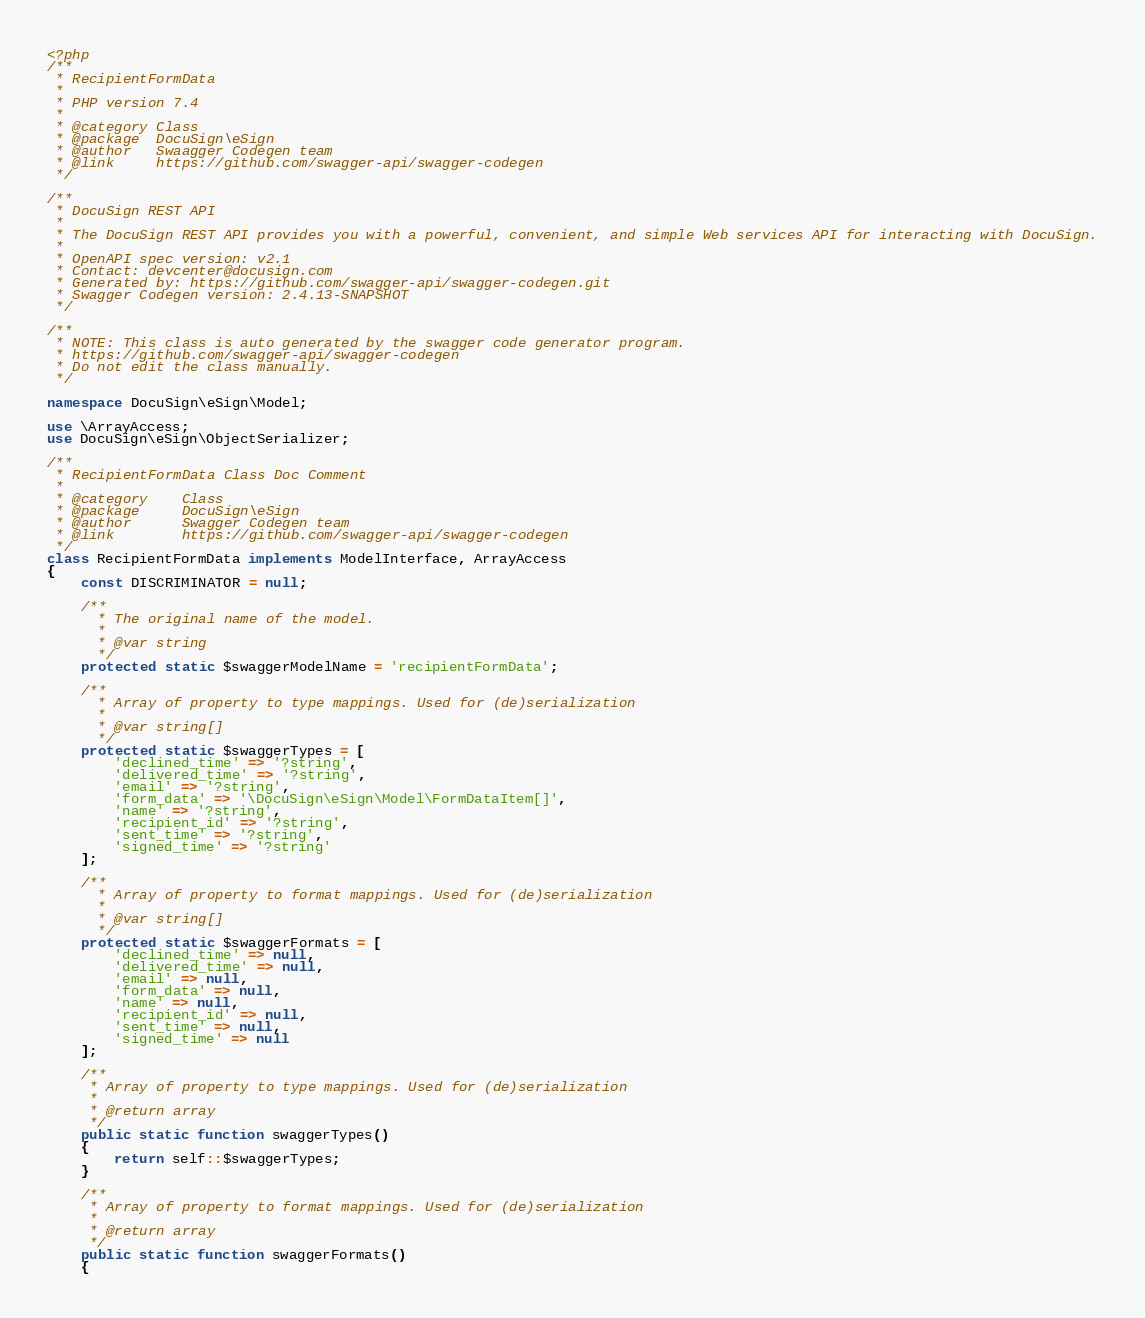<code> <loc_0><loc_0><loc_500><loc_500><_PHP_><?php
/**
 * RecipientFormData
 *
 * PHP version 7.4
 *
 * @category Class
 * @package  DocuSign\eSign
 * @author   Swaagger Codegen team
 * @link     https://github.com/swagger-api/swagger-codegen
 */

/**
 * DocuSign REST API
 *
 * The DocuSign REST API provides you with a powerful, convenient, and simple Web services API for interacting with DocuSign.
 *
 * OpenAPI spec version: v2.1
 * Contact: devcenter@docusign.com
 * Generated by: https://github.com/swagger-api/swagger-codegen.git
 * Swagger Codegen version: 2.4.13-SNAPSHOT
 */

/**
 * NOTE: This class is auto generated by the swagger code generator program.
 * https://github.com/swagger-api/swagger-codegen
 * Do not edit the class manually.
 */

namespace DocuSign\eSign\Model;

use \ArrayAccess;
use DocuSign\eSign\ObjectSerializer;

/**
 * RecipientFormData Class Doc Comment
 *
 * @category    Class
 * @package     DocuSign\eSign
 * @author      Swagger Codegen team
 * @link        https://github.com/swagger-api/swagger-codegen
 */
class RecipientFormData implements ModelInterface, ArrayAccess
{
    const DISCRIMINATOR = null;

    /**
      * The original name of the model.
      *
      * @var string
      */
    protected static $swaggerModelName = 'recipientFormData';

    /**
      * Array of property to type mappings. Used for (de)serialization
      *
      * @var string[]
      */
    protected static $swaggerTypes = [
        'declined_time' => '?string',
        'delivered_time' => '?string',
        'email' => '?string',
        'form_data' => '\DocuSign\eSign\Model\FormDataItem[]',
        'name' => '?string',
        'recipient_id' => '?string',
        'sent_time' => '?string',
        'signed_time' => '?string'
    ];

    /**
      * Array of property to format mappings. Used for (de)serialization
      *
      * @var string[]
      */
    protected static $swaggerFormats = [
        'declined_time' => null,
        'delivered_time' => null,
        'email' => null,
        'form_data' => null,
        'name' => null,
        'recipient_id' => null,
        'sent_time' => null,
        'signed_time' => null
    ];

    /**
     * Array of property to type mappings. Used for (de)serialization
     *
     * @return array
     */
    public static function swaggerTypes()
    {
        return self::$swaggerTypes;
    }

    /**
     * Array of property to format mappings. Used for (de)serialization
     *
     * @return array
     */
    public static function swaggerFormats()
    {</code> 